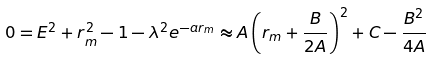<formula> <loc_0><loc_0><loc_500><loc_500>0 = E ^ { 2 } + r _ { m } ^ { 2 } - 1 - \lambda ^ { 2 } e ^ { - a r _ { m } } \approx A \left ( r _ { m } + \frac { B } { 2 A } \right ) ^ { 2 } + C - \frac { B ^ { 2 } } { 4 A }</formula> 